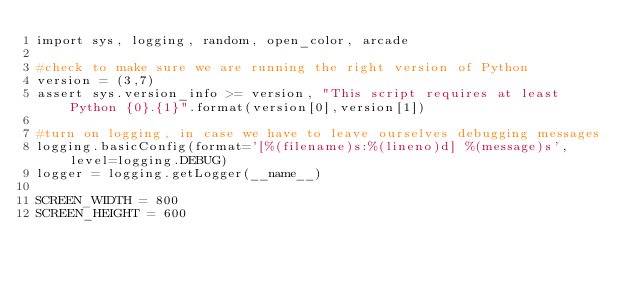Convert code to text. <code><loc_0><loc_0><loc_500><loc_500><_Python_>import sys, logging, random, open_color, arcade

#check to make sure we are running the right version of Python
version = (3,7)
assert sys.version_info >= version, "This script requires at least Python {0}.{1}".format(version[0],version[1])

#turn on logging, in case we have to leave ourselves debugging messages
logging.basicConfig(format='[%(filename)s:%(lineno)d] %(message)s', level=logging.DEBUG)
logger = logging.getLogger(__name__)

SCREEN_WIDTH = 800
SCREEN_HEIGHT = 600</code> 